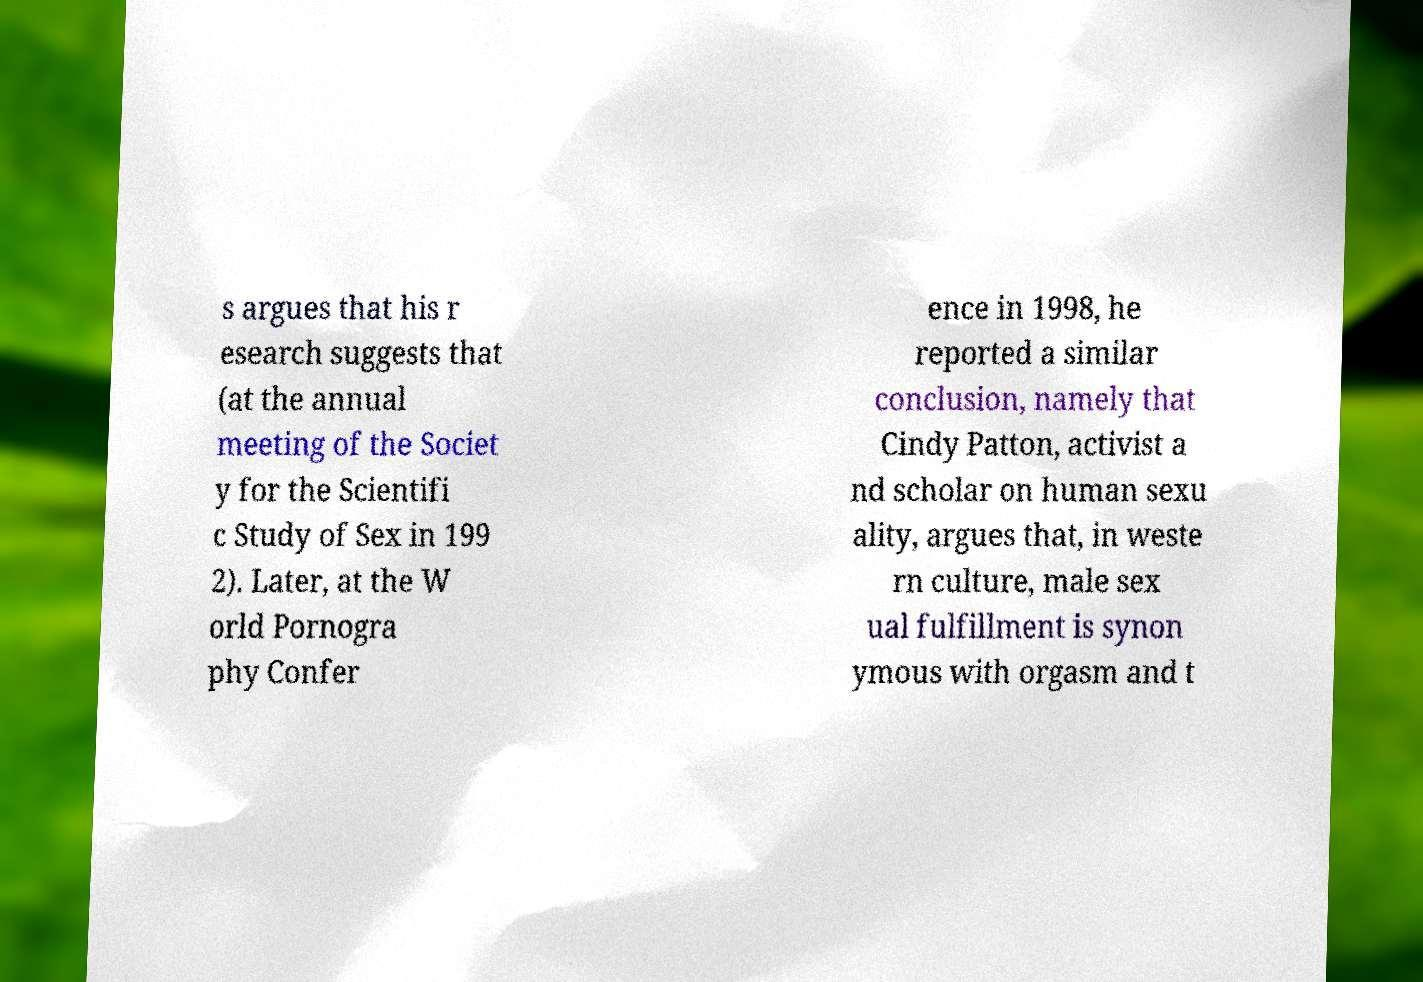There's text embedded in this image that I need extracted. Can you transcribe it verbatim? s argues that his r esearch suggests that (at the annual meeting of the Societ y for the Scientifi c Study of Sex in 199 2). Later, at the W orld Pornogra phy Confer ence in 1998, he reported a similar conclusion, namely that Cindy Patton, activist a nd scholar on human sexu ality, argues that, in weste rn culture, male sex ual fulfillment is synon ymous with orgasm and t 